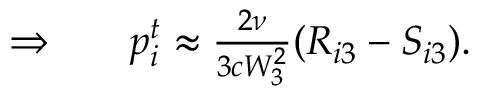Convert formula to latex. <formula><loc_0><loc_0><loc_500><loc_500>\begin{array} { r l r } { \Rightarrow } & { p _ { i } ^ { t } \approx \frac { 2 \nu } { 3 c W _ { 3 } ^ { 2 } } ( R _ { i 3 } - S _ { i 3 } ) . } \end{array}</formula> 